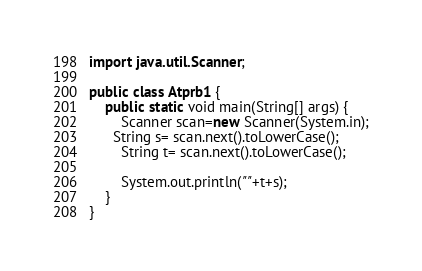<code> <loc_0><loc_0><loc_500><loc_500><_Java_>import java.util.Scanner;

public class Atprb1 {
    public static void main(String[] args) {
        Scanner scan=new Scanner(System.in);
      String s= scan.next().toLowerCase();
        String t= scan.next().toLowerCase();

        System.out.println(""+t+s);
    }
}
</code> 